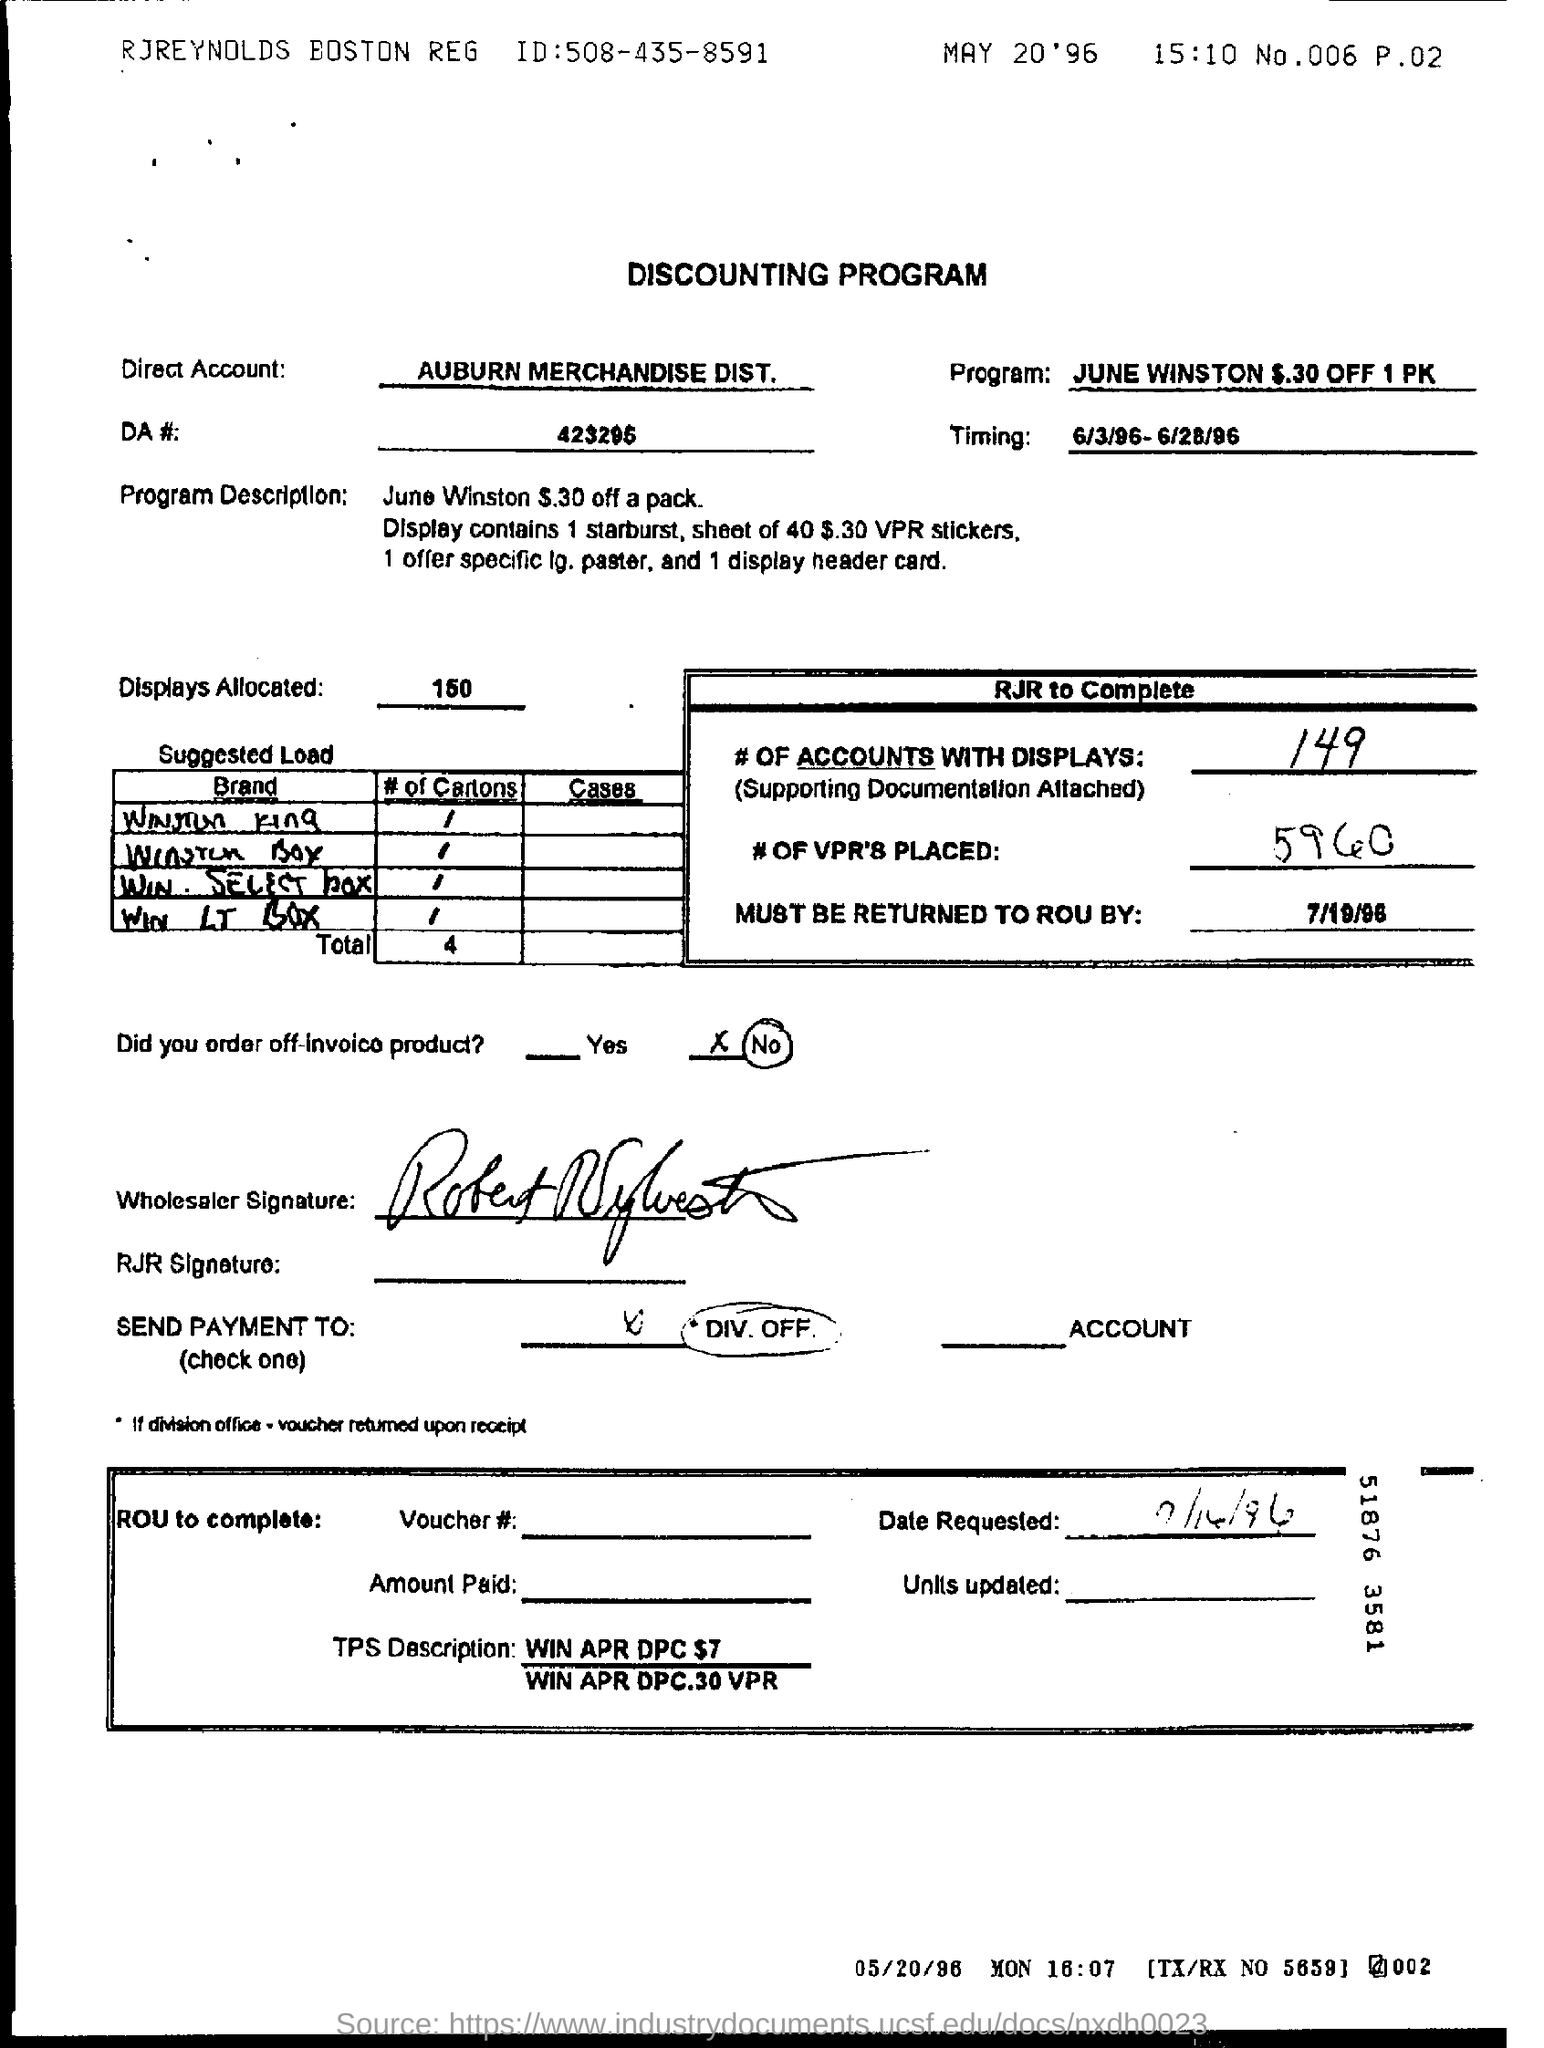Highlight a few significant elements in this photo. There are 5,960 Vehicle Positioning Reports (VPRs) placed. The timing mentioned in the document is from 6/3/96 to 6/28/96. The Direct Account mentioned in the text is Auburn Merchandise Distributor. There are 149 accounts that have displays. The number of displays allocated is 150. 